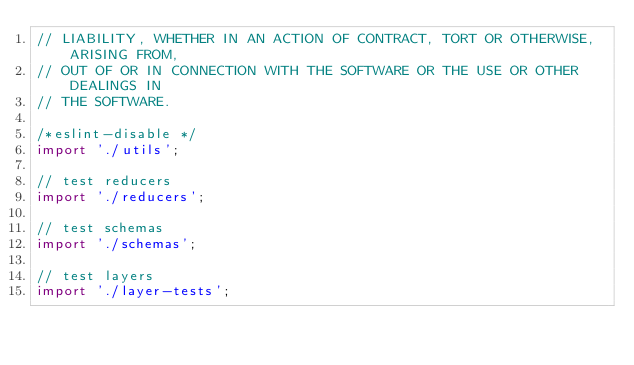<code> <loc_0><loc_0><loc_500><loc_500><_JavaScript_>// LIABILITY, WHETHER IN AN ACTION OF CONTRACT, TORT OR OTHERWISE, ARISING FROM,
// OUT OF OR IN CONNECTION WITH THE SOFTWARE OR THE USE OR OTHER DEALINGS IN
// THE SOFTWARE.

/*eslint-disable */
import './utils';

// test reducers
import './reducers';

// test schemas
import './schemas';

// test layers
import './layer-tests';
</code> 